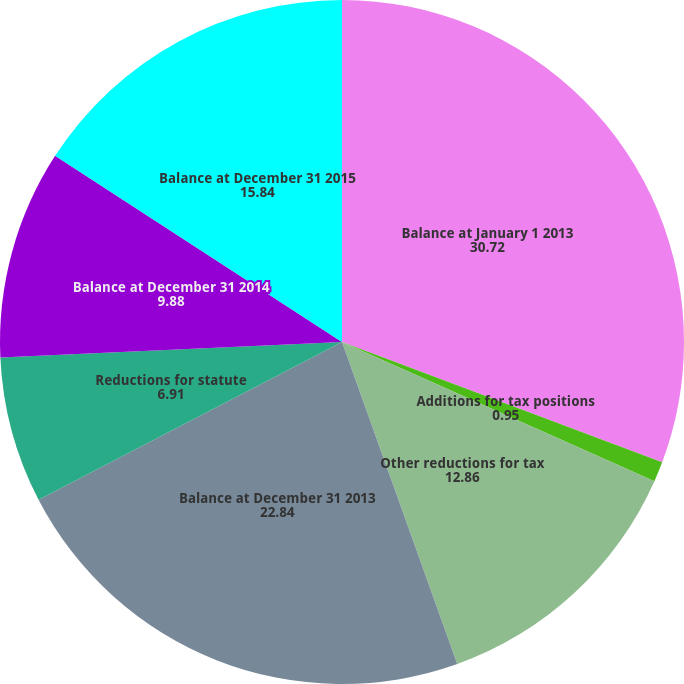Convert chart to OTSL. <chart><loc_0><loc_0><loc_500><loc_500><pie_chart><fcel>Balance at January 1 2013<fcel>Additions for tax positions<fcel>Other reductions for tax<fcel>Balance at December 31 2013<fcel>Reductions for statute<fcel>Balance at December 31 2014<fcel>Balance at December 31 2015<nl><fcel>30.72%<fcel>0.95%<fcel>12.86%<fcel>22.84%<fcel>6.91%<fcel>9.88%<fcel>15.84%<nl></chart> 